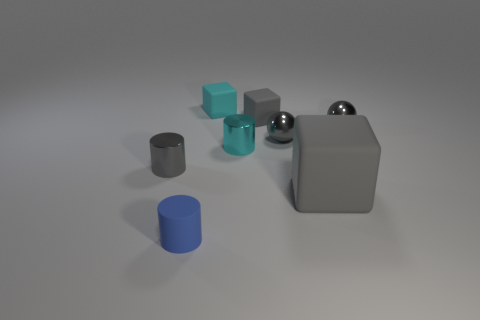There is a gray matte object that is on the right side of the small gray rubber cube; what shape is it?
Give a very brief answer. Cube. Is the shape of the object on the left side of the small rubber cylinder the same as  the small blue matte thing?
Your answer should be compact. Yes. How many objects are either small matte things behind the big gray matte object or large cubes?
Your answer should be very brief. 3. There is another tiny matte thing that is the same shape as the small gray matte object; what color is it?
Keep it short and to the point. Cyan. Are there any other things that have the same color as the large rubber block?
Make the answer very short. Yes. What is the size of the gray matte thing that is in front of the gray metal cylinder?
Keep it short and to the point. Large. Is the color of the big cube the same as the small rubber block to the right of the tiny cyan cube?
Offer a very short reply. Yes. How many other things are there of the same material as the small cyan cylinder?
Make the answer very short. 3. Is the number of tiny shiny objects greater than the number of things?
Your answer should be compact. No. Do the metal sphere on the right side of the large object and the small rubber cylinder have the same color?
Your answer should be very brief. No. 